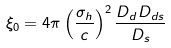<formula> <loc_0><loc_0><loc_500><loc_500>\xi _ { 0 } = 4 \pi \left ( \frac { \sigma _ { h } } { c } \right ) ^ { 2 } \frac { D _ { d } D _ { d s } } { D _ { s } }</formula> 